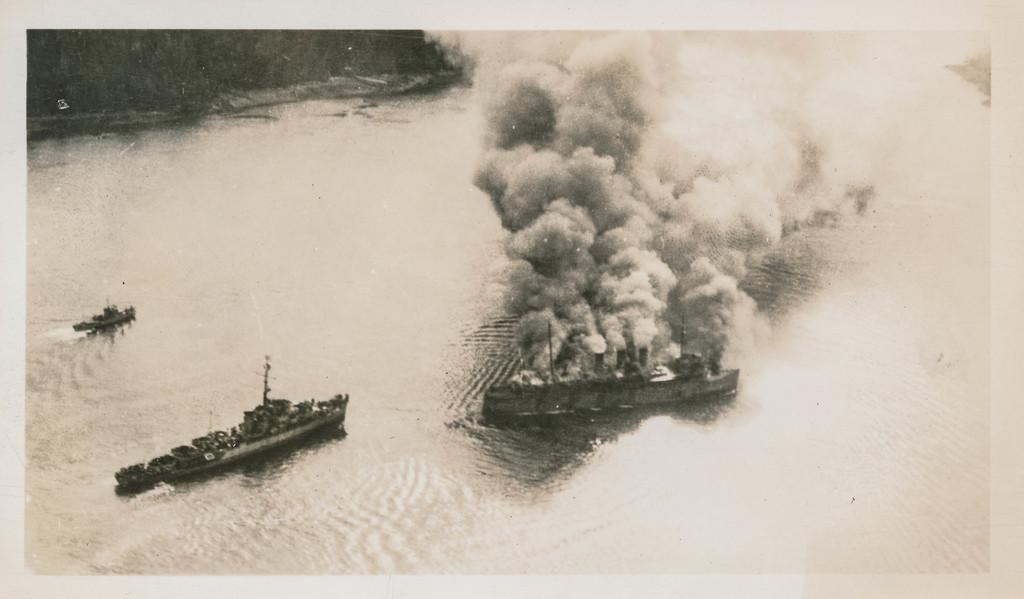What is the color scheme of the image? The image is black and white. What can be seen on the water in the image? There are boats on the water in the image. What is visible in the air in the image? There is smoke visible in the image. Can you describe any other objects in the image? There are unspecified objects in the image. What type of amusement park can be seen in the image? There is no amusement park present in the image. What flavor of cream is being used in the image? There is no cream present in the image. 